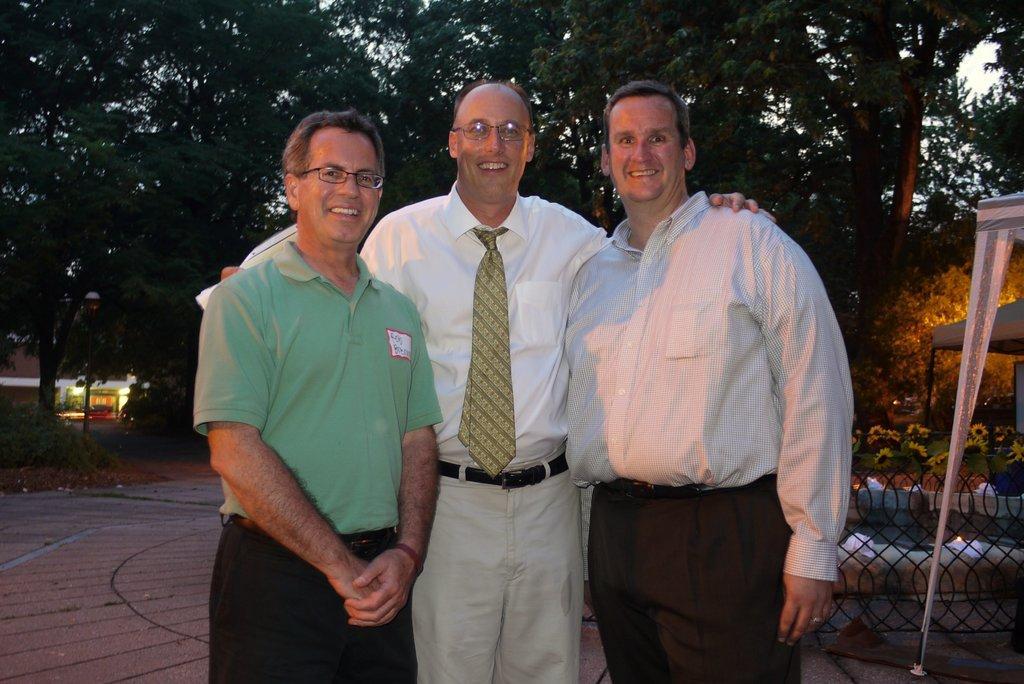Describe this image in one or two sentences. In this image we can see a group of people standing on the floor. On the right side of the image we can see a fence, tents, group of flowers and grass. On the left side of the image we can see a building with some lights. At the top of the image we can see a group of trees. 